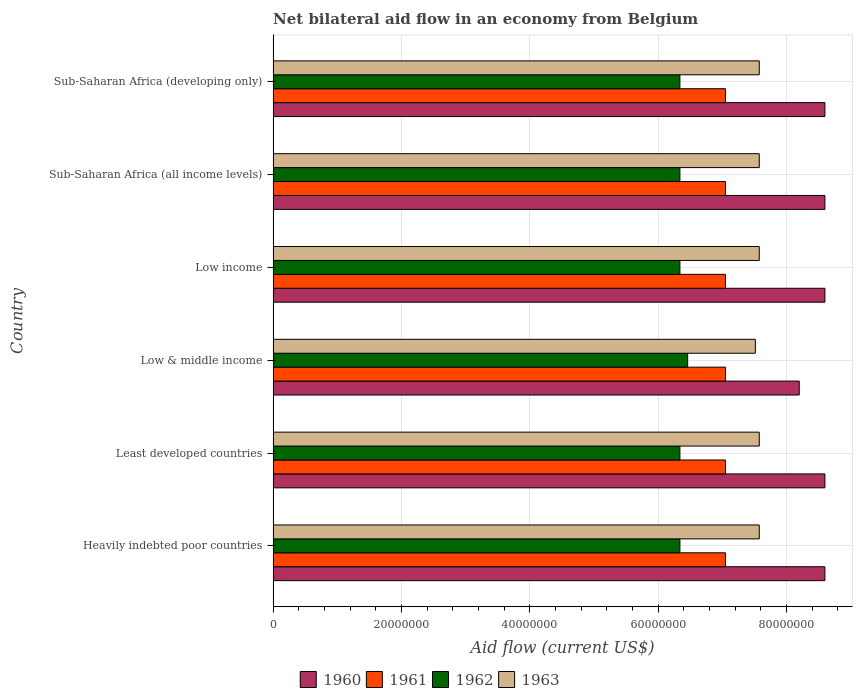How many groups of bars are there?
Your answer should be very brief. 6. Are the number of bars per tick equal to the number of legend labels?
Your answer should be compact. Yes. Are the number of bars on each tick of the Y-axis equal?
Your response must be concise. Yes. How many bars are there on the 6th tick from the bottom?
Your answer should be compact. 4. What is the label of the 1st group of bars from the top?
Your answer should be very brief. Sub-Saharan Africa (developing only). What is the net bilateral aid flow in 1962 in Low income?
Your answer should be compact. 6.34e+07. Across all countries, what is the maximum net bilateral aid flow in 1960?
Make the answer very short. 8.60e+07. Across all countries, what is the minimum net bilateral aid flow in 1963?
Ensure brevity in your answer.  7.52e+07. In which country was the net bilateral aid flow in 1961 maximum?
Provide a short and direct response. Heavily indebted poor countries. In which country was the net bilateral aid flow in 1961 minimum?
Keep it short and to the point. Heavily indebted poor countries. What is the total net bilateral aid flow in 1960 in the graph?
Your response must be concise. 5.12e+08. What is the difference between the net bilateral aid flow in 1960 in Least developed countries and that in Sub-Saharan Africa (all income levels)?
Offer a terse response. 0. What is the difference between the net bilateral aid flow in 1963 in Sub-Saharan Africa (all income levels) and the net bilateral aid flow in 1961 in Low income?
Keep it short and to the point. 5.27e+06. What is the average net bilateral aid flow in 1960 per country?
Give a very brief answer. 8.53e+07. What is the difference between the net bilateral aid flow in 1961 and net bilateral aid flow in 1962 in Sub-Saharan Africa (all income levels)?
Make the answer very short. 7.10e+06. In how many countries, is the net bilateral aid flow in 1963 greater than 76000000 US$?
Provide a short and direct response. 0. Is the net bilateral aid flow in 1962 in Least developed countries less than that in Low income?
Provide a succinct answer. No. What is the difference between the highest and the lowest net bilateral aid flow in 1960?
Give a very brief answer. 4.00e+06. Is the sum of the net bilateral aid flow in 1960 in Heavily indebted poor countries and Low income greater than the maximum net bilateral aid flow in 1962 across all countries?
Keep it short and to the point. Yes. Is it the case that in every country, the sum of the net bilateral aid flow in 1963 and net bilateral aid flow in 1961 is greater than the sum of net bilateral aid flow in 1960 and net bilateral aid flow in 1962?
Your answer should be compact. Yes. How many bars are there?
Your response must be concise. 24. How many countries are there in the graph?
Your response must be concise. 6. What is the difference between two consecutive major ticks on the X-axis?
Keep it short and to the point. 2.00e+07. Are the values on the major ticks of X-axis written in scientific E-notation?
Ensure brevity in your answer.  No. Does the graph contain any zero values?
Give a very brief answer. No. Does the graph contain grids?
Your answer should be compact. Yes. How many legend labels are there?
Your answer should be very brief. 4. How are the legend labels stacked?
Offer a very short reply. Horizontal. What is the title of the graph?
Give a very brief answer. Net bilateral aid flow in an economy from Belgium. Does "1969" appear as one of the legend labels in the graph?
Provide a short and direct response. No. What is the label or title of the Y-axis?
Provide a short and direct response. Country. What is the Aid flow (current US$) in 1960 in Heavily indebted poor countries?
Make the answer very short. 8.60e+07. What is the Aid flow (current US$) of 1961 in Heavily indebted poor countries?
Keep it short and to the point. 7.05e+07. What is the Aid flow (current US$) in 1962 in Heavily indebted poor countries?
Give a very brief answer. 6.34e+07. What is the Aid flow (current US$) in 1963 in Heavily indebted poor countries?
Make the answer very short. 7.58e+07. What is the Aid flow (current US$) of 1960 in Least developed countries?
Give a very brief answer. 8.60e+07. What is the Aid flow (current US$) of 1961 in Least developed countries?
Provide a succinct answer. 7.05e+07. What is the Aid flow (current US$) of 1962 in Least developed countries?
Provide a short and direct response. 6.34e+07. What is the Aid flow (current US$) in 1963 in Least developed countries?
Give a very brief answer. 7.58e+07. What is the Aid flow (current US$) in 1960 in Low & middle income?
Your answer should be very brief. 8.20e+07. What is the Aid flow (current US$) of 1961 in Low & middle income?
Offer a terse response. 7.05e+07. What is the Aid flow (current US$) of 1962 in Low & middle income?
Give a very brief answer. 6.46e+07. What is the Aid flow (current US$) in 1963 in Low & middle income?
Make the answer very short. 7.52e+07. What is the Aid flow (current US$) in 1960 in Low income?
Your response must be concise. 8.60e+07. What is the Aid flow (current US$) of 1961 in Low income?
Provide a short and direct response. 7.05e+07. What is the Aid flow (current US$) in 1962 in Low income?
Keep it short and to the point. 6.34e+07. What is the Aid flow (current US$) of 1963 in Low income?
Keep it short and to the point. 7.58e+07. What is the Aid flow (current US$) of 1960 in Sub-Saharan Africa (all income levels)?
Your answer should be very brief. 8.60e+07. What is the Aid flow (current US$) of 1961 in Sub-Saharan Africa (all income levels)?
Offer a terse response. 7.05e+07. What is the Aid flow (current US$) of 1962 in Sub-Saharan Africa (all income levels)?
Give a very brief answer. 6.34e+07. What is the Aid flow (current US$) in 1963 in Sub-Saharan Africa (all income levels)?
Your response must be concise. 7.58e+07. What is the Aid flow (current US$) of 1960 in Sub-Saharan Africa (developing only)?
Ensure brevity in your answer.  8.60e+07. What is the Aid flow (current US$) in 1961 in Sub-Saharan Africa (developing only)?
Make the answer very short. 7.05e+07. What is the Aid flow (current US$) of 1962 in Sub-Saharan Africa (developing only)?
Offer a very short reply. 6.34e+07. What is the Aid flow (current US$) in 1963 in Sub-Saharan Africa (developing only)?
Provide a succinct answer. 7.58e+07. Across all countries, what is the maximum Aid flow (current US$) in 1960?
Make the answer very short. 8.60e+07. Across all countries, what is the maximum Aid flow (current US$) in 1961?
Ensure brevity in your answer.  7.05e+07. Across all countries, what is the maximum Aid flow (current US$) in 1962?
Offer a very short reply. 6.46e+07. Across all countries, what is the maximum Aid flow (current US$) of 1963?
Keep it short and to the point. 7.58e+07. Across all countries, what is the minimum Aid flow (current US$) of 1960?
Ensure brevity in your answer.  8.20e+07. Across all countries, what is the minimum Aid flow (current US$) of 1961?
Offer a terse response. 7.05e+07. Across all countries, what is the minimum Aid flow (current US$) in 1962?
Ensure brevity in your answer.  6.34e+07. Across all countries, what is the minimum Aid flow (current US$) of 1963?
Offer a very short reply. 7.52e+07. What is the total Aid flow (current US$) in 1960 in the graph?
Provide a short and direct response. 5.12e+08. What is the total Aid flow (current US$) of 1961 in the graph?
Your answer should be compact. 4.23e+08. What is the total Aid flow (current US$) of 1962 in the graph?
Your response must be concise. 3.82e+08. What is the total Aid flow (current US$) in 1963 in the graph?
Your answer should be very brief. 4.54e+08. What is the difference between the Aid flow (current US$) of 1960 in Heavily indebted poor countries and that in Least developed countries?
Give a very brief answer. 0. What is the difference between the Aid flow (current US$) in 1962 in Heavily indebted poor countries and that in Least developed countries?
Your response must be concise. 0. What is the difference between the Aid flow (current US$) of 1963 in Heavily indebted poor countries and that in Least developed countries?
Offer a terse response. 0. What is the difference between the Aid flow (current US$) of 1961 in Heavily indebted poor countries and that in Low & middle income?
Offer a terse response. 0. What is the difference between the Aid flow (current US$) of 1962 in Heavily indebted poor countries and that in Low & middle income?
Provide a short and direct response. -1.21e+06. What is the difference between the Aid flow (current US$) of 1963 in Heavily indebted poor countries and that in Low income?
Your answer should be very brief. 0. What is the difference between the Aid flow (current US$) in 1962 in Heavily indebted poor countries and that in Sub-Saharan Africa (all income levels)?
Provide a short and direct response. 0. What is the difference between the Aid flow (current US$) of 1960 in Heavily indebted poor countries and that in Sub-Saharan Africa (developing only)?
Provide a succinct answer. 0. What is the difference between the Aid flow (current US$) in 1961 in Heavily indebted poor countries and that in Sub-Saharan Africa (developing only)?
Your response must be concise. 0. What is the difference between the Aid flow (current US$) of 1962 in Heavily indebted poor countries and that in Sub-Saharan Africa (developing only)?
Offer a terse response. 0. What is the difference between the Aid flow (current US$) of 1963 in Heavily indebted poor countries and that in Sub-Saharan Africa (developing only)?
Offer a very short reply. 0. What is the difference between the Aid flow (current US$) of 1960 in Least developed countries and that in Low & middle income?
Make the answer very short. 4.00e+06. What is the difference between the Aid flow (current US$) of 1962 in Least developed countries and that in Low & middle income?
Ensure brevity in your answer.  -1.21e+06. What is the difference between the Aid flow (current US$) of 1963 in Least developed countries and that in Low & middle income?
Give a very brief answer. 6.10e+05. What is the difference between the Aid flow (current US$) in 1960 in Least developed countries and that in Low income?
Provide a succinct answer. 0. What is the difference between the Aid flow (current US$) of 1962 in Least developed countries and that in Sub-Saharan Africa (all income levels)?
Give a very brief answer. 0. What is the difference between the Aid flow (current US$) in 1963 in Least developed countries and that in Sub-Saharan Africa (all income levels)?
Give a very brief answer. 0. What is the difference between the Aid flow (current US$) of 1960 in Least developed countries and that in Sub-Saharan Africa (developing only)?
Ensure brevity in your answer.  0. What is the difference between the Aid flow (current US$) in 1962 in Least developed countries and that in Sub-Saharan Africa (developing only)?
Make the answer very short. 0. What is the difference between the Aid flow (current US$) in 1961 in Low & middle income and that in Low income?
Make the answer very short. 0. What is the difference between the Aid flow (current US$) in 1962 in Low & middle income and that in Low income?
Keep it short and to the point. 1.21e+06. What is the difference between the Aid flow (current US$) in 1963 in Low & middle income and that in Low income?
Provide a short and direct response. -6.10e+05. What is the difference between the Aid flow (current US$) in 1961 in Low & middle income and that in Sub-Saharan Africa (all income levels)?
Provide a succinct answer. 0. What is the difference between the Aid flow (current US$) of 1962 in Low & middle income and that in Sub-Saharan Africa (all income levels)?
Make the answer very short. 1.21e+06. What is the difference between the Aid flow (current US$) in 1963 in Low & middle income and that in Sub-Saharan Africa (all income levels)?
Your answer should be compact. -6.10e+05. What is the difference between the Aid flow (current US$) in 1960 in Low & middle income and that in Sub-Saharan Africa (developing only)?
Your response must be concise. -4.00e+06. What is the difference between the Aid flow (current US$) of 1961 in Low & middle income and that in Sub-Saharan Africa (developing only)?
Keep it short and to the point. 0. What is the difference between the Aid flow (current US$) in 1962 in Low & middle income and that in Sub-Saharan Africa (developing only)?
Your response must be concise. 1.21e+06. What is the difference between the Aid flow (current US$) of 1963 in Low & middle income and that in Sub-Saharan Africa (developing only)?
Your answer should be very brief. -6.10e+05. What is the difference between the Aid flow (current US$) of 1960 in Low income and that in Sub-Saharan Africa (all income levels)?
Your answer should be compact. 0. What is the difference between the Aid flow (current US$) of 1962 in Low income and that in Sub-Saharan Africa (all income levels)?
Your answer should be very brief. 0. What is the difference between the Aid flow (current US$) in 1963 in Low income and that in Sub-Saharan Africa (all income levels)?
Ensure brevity in your answer.  0. What is the difference between the Aid flow (current US$) of 1960 in Sub-Saharan Africa (all income levels) and that in Sub-Saharan Africa (developing only)?
Provide a succinct answer. 0. What is the difference between the Aid flow (current US$) of 1961 in Sub-Saharan Africa (all income levels) and that in Sub-Saharan Africa (developing only)?
Provide a short and direct response. 0. What is the difference between the Aid flow (current US$) of 1962 in Sub-Saharan Africa (all income levels) and that in Sub-Saharan Africa (developing only)?
Your answer should be very brief. 0. What is the difference between the Aid flow (current US$) of 1963 in Sub-Saharan Africa (all income levels) and that in Sub-Saharan Africa (developing only)?
Make the answer very short. 0. What is the difference between the Aid flow (current US$) of 1960 in Heavily indebted poor countries and the Aid flow (current US$) of 1961 in Least developed countries?
Ensure brevity in your answer.  1.55e+07. What is the difference between the Aid flow (current US$) in 1960 in Heavily indebted poor countries and the Aid flow (current US$) in 1962 in Least developed countries?
Keep it short and to the point. 2.26e+07. What is the difference between the Aid flow (current US$) of 1960 in Heavily indebted poor countries and the Aid flow (current US$) of 1963 in Least developed countries?
Provide a short and direct response. 1.02e+07. What is the difference between the Aid flow (current US$) in 1961 in Heavily indebted poor countries and the Aid flow (current US$) in 1962 in Least developed countries?
Keep it short and to the point. 7.10e+06. What is the difference between the Aid flow (current US$) of 1961 in Heavily indebted poor countries and the Aid flow (current US$) of 1963 in Least developed countries?
Provide a short and direct response. -5.27e+06. What is the difference between the Aid flow (current US$) of 1962 in Heavily indebted poor countries and the Aid flow (current US$) of 1963 in Least developed countries?
Keep it short and to the point. -1.24e+07. What is the difference between the Aid flow (current US$) of 1960 in Heavily indebted poor countries and the Aid flow (current US$) of 1961 in Low & middle income?
Your answer should be very brief. 1.55e+07. What is the difference between the Aid flow (current US$) in 1960 in Heavily indebted poor countries and the Aid flow (current US$) in 1962 in Low & middle income?
Ensure brevity in your answer.  2.14e+07. What is the difference between the Aid flow (current US$) in 1960 in Heavily indebted poor countries and the Aid flow (current US$) in 1963 in Low & middle income?
Make the answer very short. 1.08e+07. What is the difference between the Aid flow (current US$) of 1961 in Heavily indebted poor countries and the Aid flow (current US$) of 1962 in Low & middle income?
Your response must be concise. 5.89e+06. What is the difference between the Aid flow (current US$) in 1961 in Heavily indebted poor countries and the Aid flow (current US$) in 1963 in Low & middle income?
Your answer should be compact. -4.66e+06. What is the difference between the Aid flow (current US$) of 1962 in Heavily indebted poor countries and the Aid flow (current US$) of 1963 in Low & middle income?
Ensure brevity in your answer.  -1.18e+07. What is the difference between the Aid flow (current US$) of 1960 in Heavily indebted poor countries and the Aid flow (current US$) of 1961 in Low income?
Offer a terse response. 1.55e+07. What is the difference between the Aid flow (current US$) in 1960 in Heavily indebted poor countries and the Aid flow (current US$) in 1962 in Low income?
Your answer should be compact. 2.26e+07. What is the difference between the Aid flow (current US$) of 1960 in Heavily indebted poor countries and the Aid flow (current US$) of 1963 in Low income?
Ensure brevity in your answer.  1.02e+07. What is the difference between the Aid flow (current US$) in 1961 in Heavily indebted poor countries and the Aid flow (current US$) in 1962 in Low income?
Provide a short and direct response. 7.10e+06. What is the difference between the Aid flow (current US$) of 1961 in Heavily indebted poor countries and the Aid flow (current US$) of 1963 in Low income?
Give a very brief answer. -5.27e+06. What is the difference between the Aid flow (current US$) in 1962 in Heavily indebted poor countries and the Aid flow (current US$) in 1963 in Low income?
Your answer should be compact. -1.24e+07. What is the difference between the Aid flow (current US$) of 1960 in Heavily indebted poor countries and the Aid flow (current US$) of 1961 in Sub-Saharan Africa (all income levels)?
Provide a short and direct response. 1.55e+07. What is the difference between the Aid flow (current US$) of 1960 in Heavily indebted poor countries and the Aid flow (current US$) of 1962 in Sub-Saharan Africa (all income levels)?
Your response must be concise. 2.26e+07. What is the difference between the Aid flow (current US$) in 1960 in Heavily indebted poor countries and the Aid flow (current US$) in 1963 in Sub-Saharan Africa (all income levels)?
Provide a succinct answer. 1.02e+07. What is the difference between the Aid flow (current US$) of 1961 in Heavily indebted poor countries and the Aid flow (current US$) of 1962 in Sub-Saharan Africa (all income levels)?
Your response must be concise. 7.10e+06. What is the difference between the Aid flow (current US$) of 1961 in Heavily indebted poor countries and the Aid flow (current US$) of 1963 in Sub-Saharan Africa (all income levels)?
Offer a terse response. -5.27e+06. What is the difference between the Aid flow (current US$) in 1962 in Heavily indebted poor countries and the Aid flow (current US$) in 1963 in Sub-Saharan Africa (all income levels)?
Provide a succinct answer. -1.24e+07. What is the difference between the Aid flow (current US$) in 1960 in Heavily indebted poor countries and the Aid flow (current US$) in 1961 in Sub-Saharan Africa (developing only)?
Provide a succinct answer. 1.55e+07. What is the difference between the Aid flow (current US$) of 1960 in Heavily indebted poor countries and the Aid flow (current US$) of 1962 in Sub-Saharan Africa (developing only)?
Offer a very short reply. 2.26e+07. What is the difference between the Aid flow (current US$) in 1960 in Heavily indebted poor countries and the Aid flow (current US$) in 1963 in Sub-Saharan Africa (developing only)?
Ensure brevity in your answer.  1.02e+07. What is the difference between the Aid flow (current US$) in 1961 in Heavily indebted poor countries and the Aid flow (current US$) in 1962 in Sub-Saharan Africa (developing only)?
Provide a short and direct response. 7.10e+06. What is the difference between the Aid flow (current US$) in 1961 in Heavily indebted poor countries and the Aid flow (current US$) in 1963 in Sub-Saharan Africa (developing only)?
Keep it short and to the point. -5.27e+06. What is the difference between the Aid flow (current US$) in 1962 in Heavily indebted poor countries and the Aid flow (current US$) in 1963 in Sub-Saharan Africa (developing only)?
Give a very brief answer. -1.24e+07. What is the difference between the Aid flow (current US$) of 1960 in Least developed countries and the Aid flow (current US$) of 1961 in Low & middle income?
Ensure brevity in your answer.  1.55e+07. What is the difference between the Aid flow (current US$) in 1960 in Least developed countries and the Aid flow (current US$) in 1962 in Low & middle income?
Your answer should be very brief. 2.14e+07. What is the difference between the Aid flow (current US$) in 1960 in Least developed countries and the Aid flow (current US$) in 1963 in Low & middle income?
Offer a very short reply. 1.08e+07. What is the difference between the Aid flow (current US$) in 1961 in Least developed countries and the Aid flow (current US$) in 1962 in Low & middle income?
Provide a short and direct response. 5.89e+06. What is the difference between the Aid flow (current US$) in 1961 in Least developed countries and the Aid flow (current US$) in 1963 in Low & middle income?
Ensure brevity in your answer.  -4.66e+06. What is the difference between the Aid flow (current US$) in 1962 in Least developed countries and the Aid flow (current US$) in 1963 in Low & middle income?
Provide a succinct answer. -1.18e+07. What is the difference between the Aid flow (current US$) of 1960 in Least developed countries and the Aid flow (current US$) of 1961 in Low income?
Your response must be concise. 1.55e+07. What is the difference between the Aid flow (current US$) in 1960 in Least developed countries and the Aid flow (current US$) in 1962 in Low income?
Provide a short and direct response. 2.26e+07. What is the difference between the Aid flow (current US$) in 1960 in Least developed countries and the Aid flow (current US$) in 1963 in Low income?
Provide a succinct answer. 1.02e+07. What is the difference between the Aid flow (current US$) in 1961 in Least developed countries and the Aid flow (current US$) in 1962 in Low income?
Keep it short and to the point. 7.10e+06. What is the difference between the Aid flow (current US$) of 1961 in Least developed countries and the Aid flow (current US$) of 1963 in Low income?
Keep it short and to the point. -5.27e+06. What is the difference between the Aid flow (current US$) of 1962 in Least developed countries and the Aid flow (current US$) of 1963 in Low income?
Keep it short and to the point. -1.24e+07. What is the difference between the Aid flow (current US$) of 1960 in Least developed countries and the Aid flow (current US$) of 1961 in Sub-Saharan Africa (all income levels)?
Provide a short and direct response. 1.55e+07. What is the difference between the Aid flow (current US$) in 1960 in Least developed countries and the Aid flow (current US$) in 1962 in Sub-Saharan Africa (all income levels)?
Give a very brief answer. 2.26e+07. What is the difference between the Aid flow (current US$) of 1960 in Least developed countries and the Aid flow (current US$) of 1963 in Sub-Saharan Africa (all income levels)?
Provide a short and direct response. 1.02e+07. What is the difference between the Aid flow (current US$) in 1961 in Least developed countries and the Aid flow (current US$) in 1962 in Sub-Saharan Africa (all income levels)?
Your answer should be very brief. 7.10e+06. What is the difference between the Aid flow (current US$) in 1961 in Least developed countries and the Aid flow (current US$) in 1963 in Sub-Saharan Africa (all income levels)?
Your answer should be compact. -5.27e+06. What is the difference between the Aid flow (current US$) in 1962 in Least developed countries and the Aid flow (current US$) in 1963 in Sub-Saharan Africa (all income levels)?
Your answer should be compact. -1.24e+07. What is the difference between the Aid flow (current US$) in 1960 in Least developed countries and the Aid flow (current US$) in 1961 in Sub-Saharan Africa (developing only)?
Offer a terse response. 1.55e+07. What is the difference between the Aid flow (current US$) of 1960 in Least developed countries and the Aid flow (current US$) of 1962 in Sub-Saharan Africa (developing only)?
Your response must be concise. 2.26e+07. What is the difference between the Aid flow (current US$) in 1960 in Least developed countries and the Aid flow (current US$) in 1963 in Sub-Saharan Africa (developing only)?
Provide a short and direct response. 1.02e+07. What is the difference between the Aid flow (current US$) of 1961 in Least developed countries and the Aid flow (current US$) of 1962 in Sub-Saharan Africa (developing only)?
Your response must be concise. 7.10e+06. What is the difference between the Aid flow (current US$) of 1961 in Least developed countries and the Aid flow (current US$) of 1963 in Sub-Saharan Africa (developing only)?
Provide a short and direct response. -5.27e+06. What is the difference between the Aid flow (current US$) in 1962 in Least developed countries and the Aid flow (current US$) in 1963 in Sub-Saharan Africa (developing only)?
Your response must be concise. -1.24e+07. What is the difference between the Aid flow (current US$) of 1960 in Low & middle income and the Aid flow (current US$) of 1961 in Low income?
Your answer should be compact. 1.15e+07. What is the difference between the Aid flow (current US$) in 1960 in Low & middle income and the Aid flow (current US$) in 1962 in Low income?
Offer a very short reply. 1.86e+07. What is the difference between the Aid flow (current US$) of 1960 in Low & middle income and the Aid flow (current US$) of 1963 in Low income?
Ensure brevity in your answer.  6.23e+06. What is the difference between the Aid flow (current US$) of 1961 in Low & middle income and the Aid flow (current US$) of 1962 in Low income?
Offer a terse response. 7.10e+06. What is the difference between the Aid flow (current US$) in 1961 in Low & middle income and the Aid flow (current US$) in 1963 in Low income?
Provide a short and direct response. -5.27e+06. What is the difference between the Aid flow (current US$) in 1962 in Low & middle income and the Aid flow (current US$) in 1963 in Low income?
Ensure brevity in your answer.  -1.12e+07. What is the difference between the Aid flow (current US$) in 1960 in Low & middle income and the Aid flow (current US$) in 1961 in Sub-Saharan Africa (all income levels)?
Make the answer very short. 1.15e+07. What is the difference between the Aid flow (current US$) of 1960 in Low & middle income and the Aid flow (current US$) of 1962 in Sub-Saharan Africa (all income levels)?
Offer a very short reply. 1.86e+07. What is the difference between the Aid flow (current US$) in 1960 in Low & middle income and the Aid flow (current US$) in 1963 in Sub-Saharan Africa (all income levels)?
Keep it short and to the point. 6.23e+06. What is the difference between the Aid flow (current US$) of 1961 in Low & middle income and the Aid flow (current US$) of 1962 in Sub-Saharan Africa (all income levels)?
Your response must be concise. 7.10e+06. What is the difference between the Aid flow (current US$) in 1961 in Low & middle income and the Aid flow (current US$) in 1963 in Sub-Saharan Africa (all income levels)?
Provide a short and direct response. -5.27e+06. What is the difference between the Aid flow (current US$) in 1962 in Low & middle income and the Aid flow (current US$) in 1963 in Sub-Saharan Africa (all income levels)?
Keep it short and to the point. -1.12e+07. What is the difference between the Aid flow (current US$) of 1960 in Low & middle income and the Aid flow (current US$) of 1961 in Sub-Saharan Africa (developing only)?
Your answer should be very brief. 1.15e+07. What is the difference between the Aid flow (current US$) in 1960 in Low & middle income and the Aid flow (current US$) in 1962 in Sub-Saharan Africa (developing only)?
Your answer should be compact. 1.86e+07. What is the difference between the Aid flow (current US$) of 1960 in Low & middle income and the Aid flow (current US$) of 1963 in Sub-Saharan Africa (developing only)?
Your answer should be compact. 6.23e+06. What is the difference between the Aid flow (current US$) in 1961 in Low & middle income and the Aid flow (current US$) in 1962 in Sub-Saharan Africa (developing only)?
Provide a succinct answer. 7.10e+06. What is the difference between the Aid flow (current US$) of 1961 in Low & middle income and the Aid flow (current US$) of 1963 in Sub-Saharan Africa (developing only)?
Your answer should be very brief. -5.27e+06. What is the difference between the Aid flow (current US$) of 1962 in Low & middle income and the Aid flow (current US$) of 1963 in Sub-Saharan Africa (developing only)?
Offer a very short reply. -1.12e+07. What is the difference between the Aid flow (current US$) in 1960 in Low income and the Aid flow (current US$) in 1961 in Sub-Saharan Africa (all income levels)?
Keep it short and to the point. 1.55e+07. What is the difference between the Aid flow (current US$) of 1960 in Low income and the Aid flow (current US$) of 1962 in Sub-Saharan Africa (all income levels)?
Offer a terse response. 2.26e+07. What is the difference between the Aid flow (current US$) of 1960 in Low income and the Aid flow (current US$) of 1963 in Sub-Saharan Africa (all income levels)?
Keep it short and to the point. 1.02e+07. What is the difference between the Aid flow (current US$) in 1961 in Low income and the Aid flow (current US$) in 1962 in Sub-Saharan Africa (all income levels)?
Make the answer very short. 7.10e+06. What is the difference between the Aid flow (current US$) of 1961 in Low income and the Aid flow (current US$) of 1963 in Sub-Saharan Africa (all income levels)?
Your answer should be very brief. -5.27e+06. What is the difference between the Aid flow (current US$) in 1962 in Low income and the Aid flow (current US$) in 1963 in Sub-Saharan Africa (all income levels)?
Provide a succinct answer. -1.24e+07. What is the difference between the Aid flow (current US$) in 1960 in Low income and the Aid flow (current US$) in 1961 in Sub-Saharan Africa (developing only)?
Ensure brevity in your answer.  1.55e+07. What is the difference between the Aid flow (current US$) in 1960 in Low income and the Aid flow (current US$) in 1962 in Sub-Saharan Africa (developing only)?
Give a very brief answer. 2.26e+07. What is the difference between the Aid flow (current US$) in 1960 in Low income and the Aid flow (current US$) in 1963 in Sub-Saharan Africa (developing only)?
Your answer should be very brief. 1.02e+07. What is the difference between the Aid flow (current US$) of 1961 in Low income and the Aid flow (current US$) of 1962 in Sub-Saharan Africa (developing only)?
Your answer should be compact. 7.10e+06. What is the difference between the Aid flow (current US$) in 1961 in Low income and the Aid flow (current US$) in 1963 in Sub-Saharan Africa (developing only)?
Your answer should be very brief. -5.27e+06. What is the difference between the Aid flow (current US$) in 1962 in Low income and the Aid flow (current US$) in 1963 in Sub-Saharan Africa (developing only)?
Your answer should be very brief. -1.24e+07. What is the difference between the Aid flow (current US$) in 1960 in Sub-Saharan Africa (all income levels) and the Aid flow (current US$) in 1961 in Sub-Saharan Africa (developing only)?
Give a very brief answer. 1.55e+07. What is the difference between the Aid flow (current US$) of 1960 in Sub-Saharan Africa (all income levels) and the Aid flow (current US$) of 1962 in Sub-Saharan Africa (developing only)?
Keep it short and to the point. 2.26e+07. What is the difference between the Aid flow (current US$) in 1960 in Sub-Saharan Africa (all income levels) and the Aid flow (current US$) in 1963 in Sub-Saharan Africa (developing only)?
Offer a terse response. 1.02e+07. What is the difference between the Aid flow (current US$) of 1961 in Sub-Saharan Africa (all income levels) and the Aid flow (current US$) of 1962 in Sub-Saharan Africa (developing only)?
Offer a very short reply. 7.10e+06. What is the difference between the Aid flow (current US$) in 1961 in Sub-Saharan Africa (all income levels) and the Aid flow (current US$) in 1963 in Sub-Saharan Africa (developing only)?
Provide a succinct answer. -5.27e+06. What is the difference between the Aid flow (current US$) in 1962 in Sub-Saharan Africa (all income levels) and the Aid flow (current US$) in 1963 in Sub-Saharan Africa (developing only)?
Keep it short and to the point. -1.24e+07. What is the average Aid flow (current US$) of 1960 per country?
Provide a short and direct response. 8.53e+07. What is the average Aid flow (current US$) of 1961 per country?
Give a very brief answer. 7.05e+07. What is the average Aid flow (current US$) of 1962 per country?
Keep it short and to the point. 6.36e+07. What is the average Aid flow (current US$) in 1963 per country?
Provide a succinct answer. 7.57e+07. What is the difference between the Aid flow (current US$) in 1960 and Aid flow (current US$) in 1961 in Heavily indebted poor countries?
Your answer should be very brief. 1.55e+07. What is the difference between the Aid flow (current US$) in 1960 and Aid flow (current US$) in 1962 in Heavily indebted poor countries?
Keep it short and to the point. 2.26e+07. What is the difference between the Aid flow (current US$) in 1960 and Aid flow (current US$) in 1963 in Heavily indebted poor countries?
Give a very brief answer. 1.02e+07. What is the difference between the Aid flow (current US$) of 1961 and Aid flow (current US$) of 1962 in Heavily indebted poor countries?
Give a very brief answer. 7.10e+06. What is the difference between the Aid flow (current US$) in 1961 and Aid flow (current US$) in 1963 in Heavily indebted poor countries?
Your response must be concise. -5.27e+06. What is the difference between the Aid flow (current US$) of 1962 and Aid flow (current US$) of 1963 in Heavily indebted poor countries?
Make the answer very short. -1.24e+07. What is the difference between the Aid flow (current US$) in 1960 and Aid flow (current US$) in 1961 in Least developed countries?
Make the answer very short. 1.55e+07. What is the difference between the Aid flow (current US$) of 1960 and Aid flow (current US$) of 1962 in Least developed countries?
Make the answer very short. 2.26e+07. What is the difference between the Aid flow (current US$) of 1960 and Aid flow (current US$) of 1963 in Least developed countries?
Your response must be concise. 1.02e+07. What is the difference between the Aid flow (current US$) of 1961 and Aid flow (current US$) of 1962 in Least developed countries?
Your answer should be very brief. 7.10e+06. What is the difference between the Aid flow (current US$) of 1961 and Aid flow (current US$) of 1963 in Least developed countries?
Make the answer very short. -5.27e+06. What is the difference between the Aid flow (current US$) of 1962 and Aid flow (current US$) of 1963 in Least developed countries?
Provide a short and direct response. -1.24e+07. What is the difference between the Aid flow (current US$) of 1960 and Aid flow (current US$) of 1961 in Low & middle income?
Offer a very short reply. 1.15e+07. What is the difference between the Aid flow (current US$) of 1960 and Aid flow (current US$) of 1962 in Low & middle income?
Offer a very short reply. 1.74e+07. What is the difference between the Aid flow (current US$) in 1960 and Aid flow (current US$) in 1963 in Low & middle income?
Offer a terse response. 6.84e+06. What is the difference between the Aid flow (current US$) in 1961 and Aid flow (current US$) in 1962 in Low & middle income?
Offer a very short reply. 5.89e+06. What is the difference between the Aid flow (current US$) in 1961 and Aid flow (current US$) in 1963 in Low & middle income?
Offer a terse response. -4.66e+06. What is the difference between the Aid flow (current US$) in 1962 and Aid flow (current US$) in 1963 in Low & middle income?
Give a very brief answer. -1.06e+07. What is the difference between the Aid flow (current US$) in 1960 and Aid flow (current US$) in 1961 in Low income?
Give a very brief answer. 1.55e+07. What is the difference between the Aid flow (current US$) of 1960 and Aid flow (current US$) of 1962 in Low income?
Provide a short and direct response. 2.26e+07. What is the difference between the Aid flow (current US$) of 1960 and Aid flow (current US$) of 1963 in Low income?
Your answer should be very brief. 1.02e+07. What is the difference between the Aid flow (current US$) in 1961 and Aid flow (current US$) in 1962 in Low income?
Offer a terse response. 7.10e+06. What is the difference between the Aid flow (current US$) of 1961 and Aid flow (current US$) of 1963 in Low income?
Your answer should be very brief. -5.27e+06. What is the difference between the Aid flow (current US$) in 1962 and Aid flow (current US$) in 1963 in Low income?
Keep it short and to the point. -1.24e+07. What is the difference between the Aid flow (current US$) of 1960 and Aid flow (current US$) of 1961 in Sub-Saharan Africa (all income levels)?
Make the answer very short. 1.55e+07. What is the difference between the Aid flow (current US$) in 1960 and Aid flow (current US$) in 1962 in Sub-Saharan Africa (all income levels)?
Make the answer very short. 2.26e+07. What is the difference between the Aid flow (current US$) in 1960 and Aid flow (current US$) in 1963 in Sub-Saharan Africa (all income levels)?
Make the answer very short. 1.02e+07. What is the difference between the Aid flow (current US$) in 1961 and Aid flow (current US$) in 1962 in Sub-Saharan Africa (all income levels)?
Offer a very short reply. 7.10e+06. What is the difference between the Aid flow (current US$) in 1961 and Aid flow (current US$) in 1963 in Sub-Saharan Africa (all income levels)?
Your response must be concise. -5.27e+06. What is the difference between the Aid flow (current US$) in 1962 and Aid flow (current US$) in 1963 in Sub-Saharan Africa (all income levels)?
Offer a very short reply. -1.24e+07. What is the difference between the Aid flow (current US$) of 1960 and Aid flow (current US$) of 1961 in Sub-Saharan Africa (developing only)?
Ensure brevity in your answer.  1.55e+07. What is the difference between the Aid flow (current US$) in 1960 and Aid flow (current US$) in 1962 in Sub-Saharan Africa (developing only)?
Give a very brief answer. 2.26e+07. What is the difference between the Aid flow (current US$) in 1960 and Aid flow (current US$) in 1963 in Sub-Saharan Africa (developing only)?
Your response must be concise. 1.02e+07. What is the difference between the Aid flow (current US$) of 1961 and Aid flow (current US$) of 1962 in Sub-Saharan Africa (developing only)?
Offer a very short reply. 7.10e+06. What is the difference between the Aid flow (current US$) in 1961 and Aid flow (current US$) in 1963 in Sub-Saharan Africa (developing only)?
Give a very brief answer. -5.27e+06. What is the difference between the Aid flow (current US$) in 1962 and Aid flow (current US$) in 1963 in Sub-Saharan Africa (developing only)?
Ensure brevity in your answer.  -1.24e+07. What is the ratio of the Aid flow (current US$) in 1961 in Heavily indebted poor countries to that in Least developed countries?
Provide a succinct answer. 1. What is the ratio of the Aid flow (current US$) in 1963 in Heavily indebted poor countries to that in Least developed countries?
Give a very brief answer. 1. What is the ratio of the Aid flow (current US$) in 1960 in Heavily indebted poor countries to that in Low & middle income?
Your answer should be very brief. 1.05. What is the ratio of the Aid flow (current US$) of 1962 in Heavily indebted poor countries to that in Low & middle income?
Your answer should be compact. 0.98. What is the ratio of the Aid flow (current US$) in 1962 in Heavily indebted poor countries to that in Low income?
Your response must be concise. 1. What is the ratio of the Aid flow (current US$) in 1963 in Heavily indebted poor countries to that in Low income?
Provide a succinct answer. 1. What is the ratio of the Aid flow (current US$) of 1960 in Heavily indebted poor countries to that in Sub-Saharan Africa (developing only)?
Your answer should be compact. 1. What is the ratio of the Aid flow (current US$) in 1962 in Heavily indebted poor countries to that in Sub-Saharan Africa (developing only)?
Your answer should be compact. 1. What is the ratio of the Aid flow (current US$) of 1960 in Least developed countries to that in Low & middle income?
Offer a terse response. 1.05. What is the ratio of the Aid flow (current US$) in 1961 in Least developed countries to that in Low & middle income?
Make the answer very short. 1. What is the ratio of the Aid flow (current US$) of 1962 in Least developed countries to that in Low & middle income?
Keep it short and to the point. 0.98. What is the ratio of the Aid flow (current US$) of 1963 in Least developed countries to that in Low & middle income?
Ensure brevity in your answer.  1.01. What is the ratio of the Aid flow (current US$) in 1961 in Least developed countries to that in Low income?
Provide a short and direct response. 1. What is the ratio of the Aid flow (current US$) in 1963 in Least developed countries to that in Low income?
Provide a short and direct response. 1. What is the ratio of the Aid flow (current US$) of 1960 in Least developed countries to that in Sub-Saharan Africa (all income levels)?
Give a very brief answer. 1. What is the ratio of the Aid flow (current US$) in 1962 in Least developed countries to that in Sub-Saharan Africa (all income levels)?
Your answer should be very brief. 1. What is the ratio of the Aid flow (current US$) in 1961 in Least developed countries to that in Sub-Saharan Africa (developing only)?
Make the answer very short. 1. What is the ratio of the Aid flow (current US$) in 1962 in Least developed countries to that in Sub-Saharan Africa (developing only)?
Keep it short and to the point. 1. What is the ratio of the Aid flow (current US$) of 1960 in Low & middle income to that in Low income?
Your answer should be compact. 0.95. What is the ratio of the Aid flow (current US$) in 1961 in Low & middle income to that in Low income?
Offer a terse response. 1. What is the ratio of the Aid flow (current US$) in 1962 in Low & middle income to that in Low income?
Your response must be concise. 1.02. What is the ratio of the Aid flow (current US$) in 1960 in Low & middle income to that in Sub-Saharan Africa (all income levels)?
Ensure brevity in your answer.  0.95. What is the ratio of the Aid flow (current US$) of 1962 in Low & middle income to that in Sub-Saharan Africa (all income levels)?
Your response must be concise. 1.02. What is the ratio of the Aid flow (current US$) of 1963 in Low & middle income to that in Sub-Saharan Africa (all income levels)?
Keep it short and to the point. 0.99. What is the ratio of the Aid flow (current US$) in 1960 in Low & middle income to that in Sub-Saharan Africa (developing only)?
Ensure brevity in your answer.  0.95. What is the ratio of the Aid flow (current US$) in 1962 in Low & middle income to that in Sub-Saharan Africa (developing only)?
Offer a very short reply. 1.02. What is the ratio of the Aid flow (current US$) of 1963 in Low & middle income to that in Sub-Saharan Africa (developing only)?
Offer a very short reply. 0.99. What is the ratio of the Aid flow (current US$) of 1961 in Low income to that in Sub-Saharan Africa (all income levels)?
Make the answer very short. 1. What is the ratio of the Aid flow (current US$) of 1963 in Low income to that in Sub-Saharan Africa (developing only)?
Offer a terse response. 1. What is the ratio of the Aid flow (current US$) in 1961 in Sub-Saharan Africa (all income levels) to that in Sub-Saharan Africa (developing only)?
Your answer should be compact. 1. What is the difference between the highest and the second highest Aid flow (current US$) in 1960?
Provide a succinct answer. 0. What is the difference between the highest and the second highest Aid flow (current US$) in 1961?
Give a very brief answer. 0. What is the difference between the highest and the second highest Aid flow (current US$) in 1962?
Your answer should be compact. 1.21e+06. What is the difference between the highest and the lowest Aid flow (current US$) of 1962?
Keep it short and to the point. 1.21e+06. 